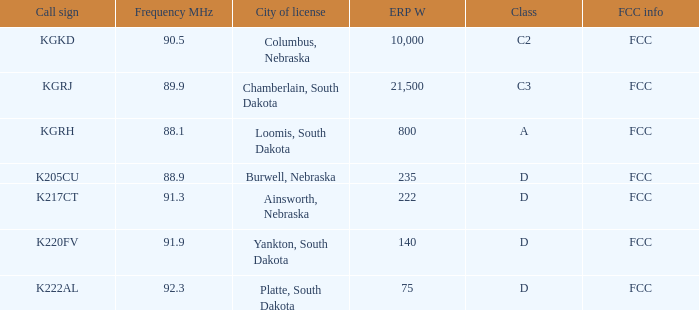What is the highest erp w with a 90.5 frequency mhz? 10000.0. 